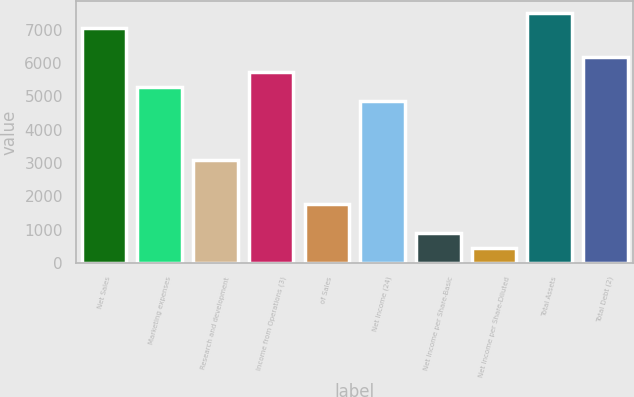Convert chart. <chart><loc_0><loc_0><loc_500><loc_500><bar_chart><fcel>Net Sales<fcel>Marketing expenses<fcel>Research and development<fcel>Income from Operations (3)<fcel>of Sales<fcel>Net Income (24)<fcel>Net Income per Share-Basic<fcel>Net Income per Share-Diluted<fcel>Total Assets<fcel>Total Debt (2)<nl><fcel>7049.15<fcel>5287.03<fcel>3084.38<fcel>5727.56<fcel>1762.79<fcel>4846.5<fcel>881.73<fcel>441.2<fcel>7489.68<fcel>6168.09<nl></chart> 